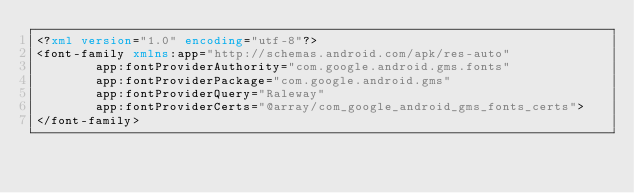Convert code to text. <code><loc_0><loc_0><loc_500><loc_500><_XML_><?xml version="1.0" encoding="utf-8"?>
<font-family xmlns:app="http://schemas.android.com/apk/res-auto"
        app:fontProviderAuthority="com.google.android.gms.fonts"
        app:fontProviderPackage="com.google.android.gms"
        app:fontProviderQuery="Raleway"
        app:fontProviderCerts="@array/com_google_android_gms_fonts_certs">
</font-family>
</code> 